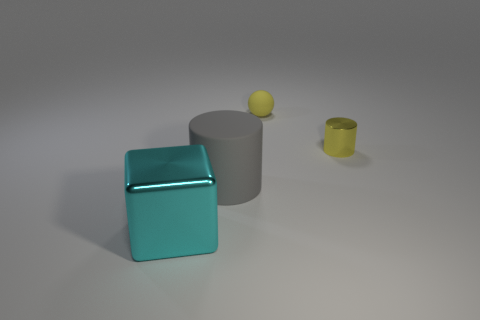Are there more big gray objects on the right side of the small yellow metal cylinder than small yellow matte spheres behind the gray rubber cylinder? Upon inspecting the image, there seems to be a single large gray object to the right of the small yellow metal cylinder, while there are no small yellow matte spheres behind the gray rubber cylinder. Therefore, the answer is yes, as there are more large gray objects in the specified area than small yellow matte spheres. 